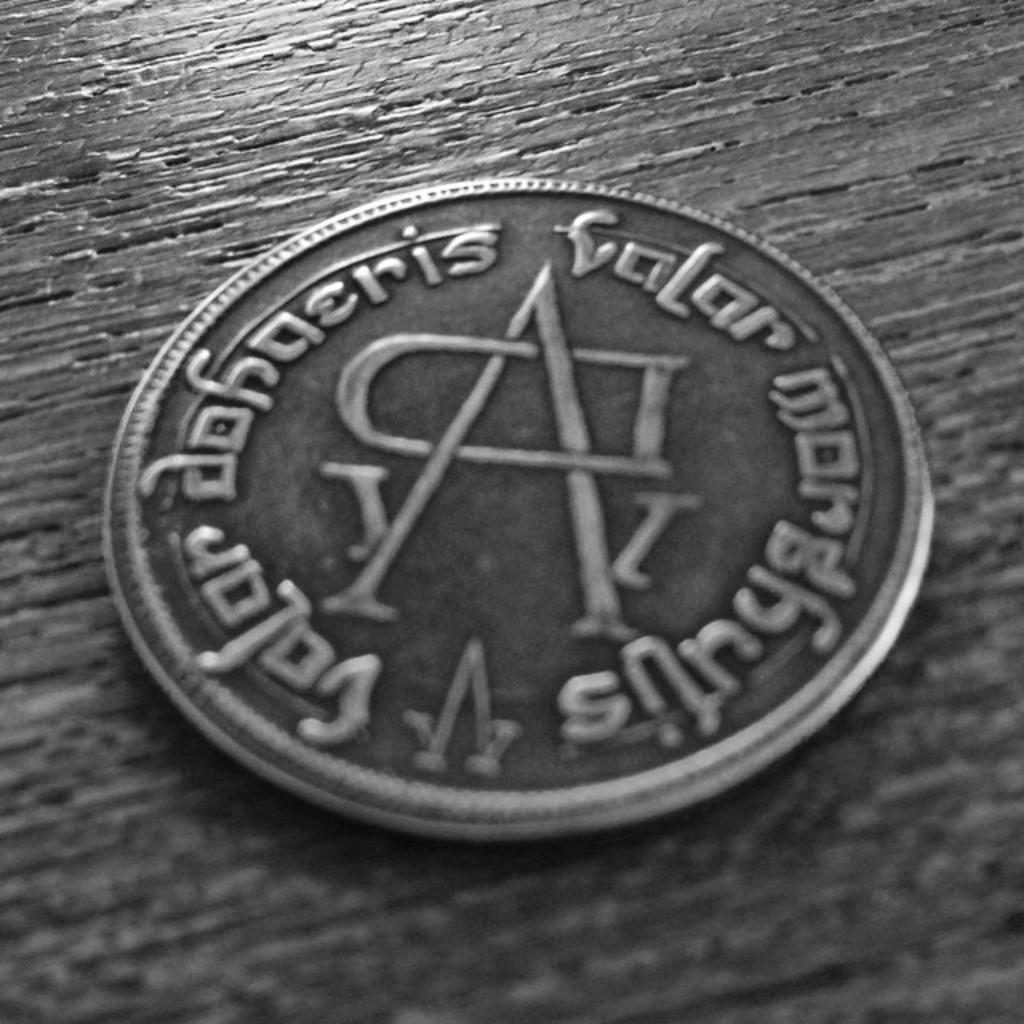<image>
Provide a brief description of the given image. a silver coin with the inscription valar dohaeris and valar morghulis 